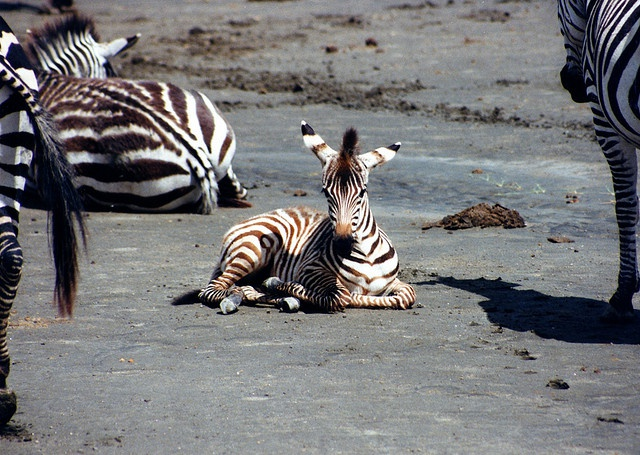Describe the objects in this image and their specific colors. I can see zebra in gray, black, white, and darkgray tones, zebra in gray, black, white, and darkgray tones, zebra in gray, black, and navy tones, and zebra in gray, black, lightgray, and darkgray tones in this image. 